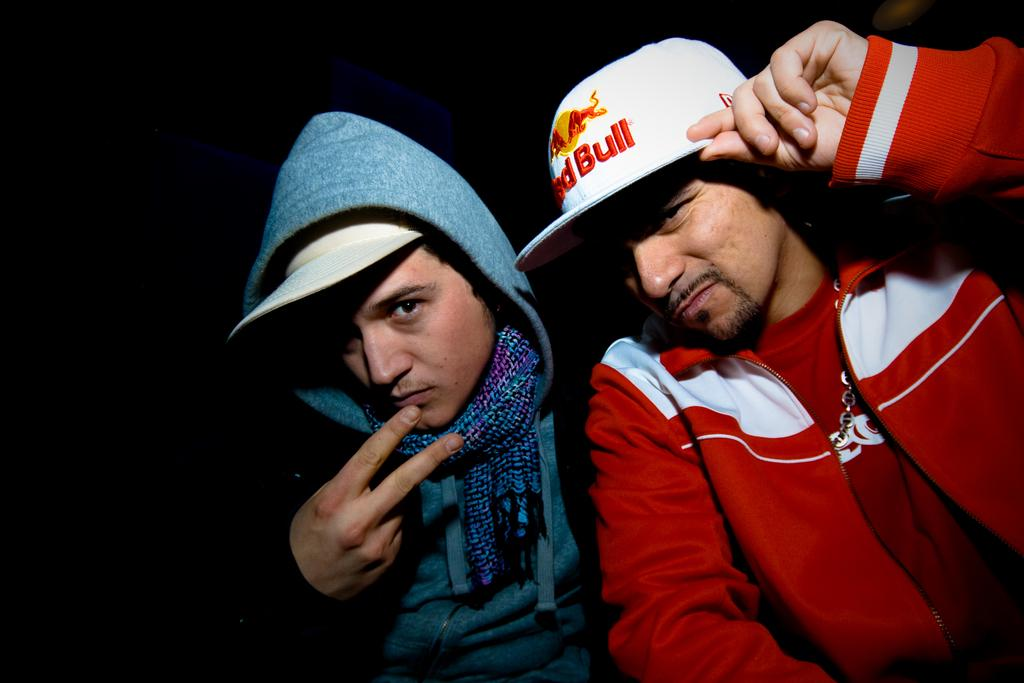<image>
Write a terse but informative summary of the picture. The man on the right is wearing a red bull hat. 